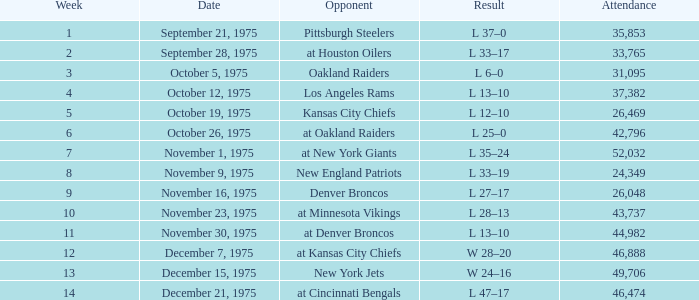What is the highest Week when the opponent was the los angeles rams, with more than 37,382 in Attendance? None. 